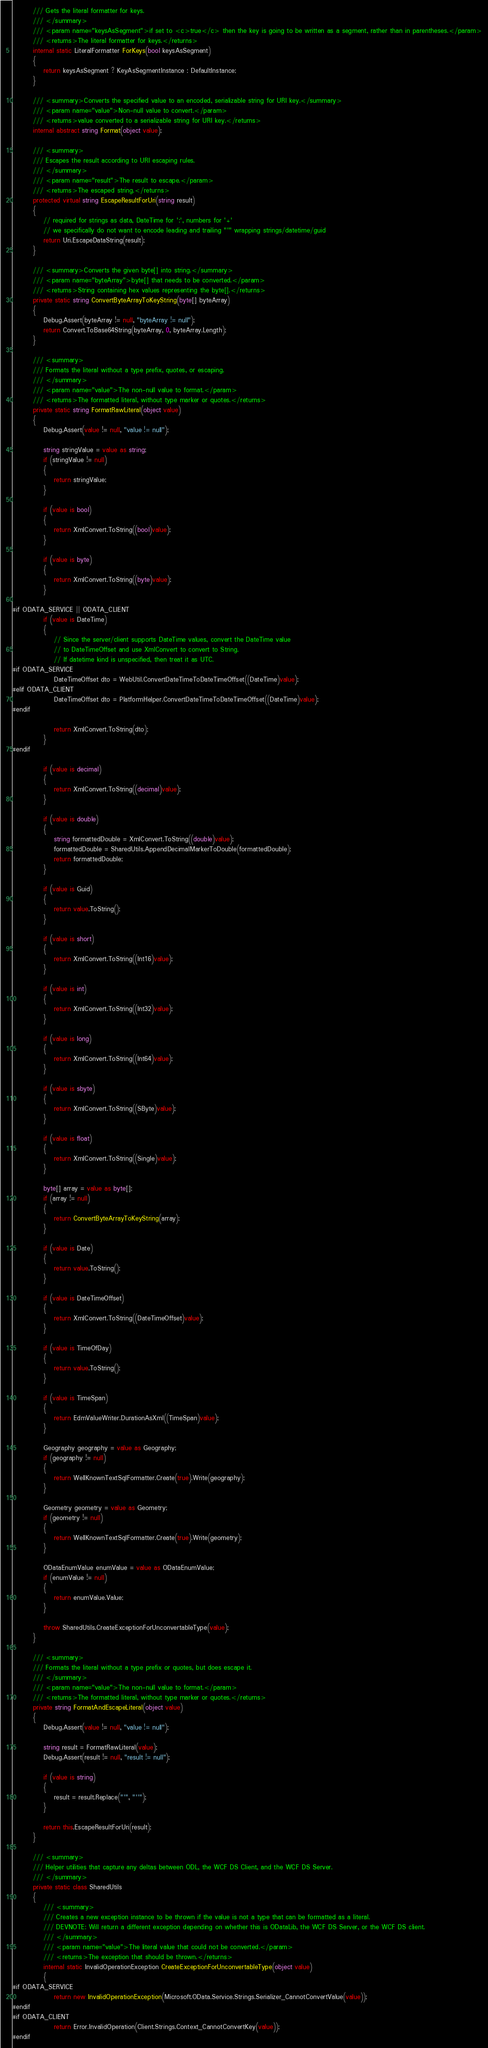Convert code to text. <code><loc_0><loc_0><loc_500><loc_500><_C#_>        /// Gets the literal formatter for keys.
        /// </summary>
        /// <param name="keysAsSegment">if set to <c>true</c> then the key is going to be written as a segment, rather than in parentheses.</param>
        /// <returns>The literal formatter for keys.</returns>
        internal static LiteralFormatter ForKeys(bool keysAsSegment)
        {
            return keysAsSegment ? KeyAsSegmentInstance : DefaultInstance;
        }

        /// <summary>Converts the specified value to an encoded, serializable string for URI key.</summary>
        /// <param name="value">Non-null value to convert.</param>
        /// <returns>value converted to a serializable string for URI key.</returns>
        internal abstract string Format(object value);

        /// <summary>
        /// Escapes the result according to URI escaping rules.
        /// </summary>
        /// <param name="result">The result to escape.</param>
        /// <returns>The escaped string.</returns>
        protected virtual string EscapeResultForUri(string result)
        {
            // required for strings as data, DateTime for ':', numbers for '+'
            // we specifically do not want to encode leading and trailing "'" wrapping strings/datetime/guid
            return Uri.EscapeDataString(result);
        }

        /// <summary>Converts the given byte[] into string.</summary>
        /// <param name="byteArray">byte[] that needs to be converted.</param>
        /// <returns>String containing hex values representing the byte[].</returns>
        private static string ConvertByteArrayToKeyString(byte[] byteArray)
        {
            Debug.Assert(byteArray != null, "byteArray != null");
            return Convert.ToBase64String(byteArray, 0, byteArray.Length);
        }

        /// <summary>
        /// Formats the literal without a type prefix, quotes, or escaping.
        /// </summary>
        /// <param name="value">The non-null value to format.</param>
        /// <returns>The formatted literal, without type marker or quotes.</returns>
        private static string FormatRawLiteral(object value)
        {
            Debug.Assert(value != null, "value != null");

            string stringValue = value as string;
            if (stringValue != null)
            {
                return stringValue;
            }

            if (value is bool)
            {
                return XmlConvert.ToString((bool)value);
            }

            if (value is byte)
            {
                return XmlConvert.ToString((byte)value);
            }

#if ODATA_SERVICE || ODATA_CLIENT
            if (value is DateTime)
            {
                // Since the server/client supports DateTime values, convert the DateTime value
                // to DateTimeOffset and use XmlConvert to convert to String.
                // If datetime kind is unspecified, then treat it as UTC.
#if ODATA_SERVICE
                DateTimeOffset dto = WebUtil.ConvertDateTimeToDateTimeOffset((DateTime)value);
#elif ODATA_CLIENT
                DateTimeOffset dto = PlatformHelper.ConvertDateTimeToDateTimeOffset((DateTime)value);
#endif

                return XmlConvert.ToString(dto);
            }
#endif

            if (value is decimal)
            {
                return XmlConvert.ToString((decimal)value);
            }

            if (value is double)
            {
                string formattedDouble = XmlConvert.ToString((double)value);
                formattedDouble = SharedUtils.AppendDecimalMarkerToDouble(formattedDouble);
                return formattedDouble;
            }

            if (value is Guid)
            {
                return value.ToString();
            }

            if (value is short)
            {
                return XmlConvert.ToString((Int16)value);
            }

            if (value is int)
            {
                return XmlConvert.ToString((Int32)value);
            }

            if (value is long)
            {
                return XmlConvert.ToString((Int64)value);
            }

            if (value is sbyte)
            {
                return XmlConvert.ToString((SByte)value);
            }

            if (value is float)
            {
                return XmlConvert.ToString((Single)value);
            }

            byte[] array = value as byte[];
            if (array != null)
            {
                return ConvertByteArrayToKeyString(array);
            }

            if (value is Date)
            {
                return value.ToString();
            }

            if (value is DateTimeOffset)
            {
                return XmlConvert.ToString((DateTimeOffset)value);
            }

            if (value is TimeOfDay)
            {
                return value.ToString();
            }

            if (value is TimeSpan)
            {
                return EdmValueWriter.DurationAsXml((TimeSpan)value);
            }

            Geography geography = value as Geography;
            if (geography != null)
            {
                return WellKnownTextSqlFormatter.Create(true).Write(geography);
            }

            Geometry geometry = value as Geometry;
            if (geometry != null)
            {
                return WellKnownTextSqlFormatter.Create(true).Write(geometry);
            }

            ODataEnumValue enumValue = value as ODataEnumValue;
            if (enumValue != null)
            {
                return enumValue.Value;
            }

            throw SharedUtils.CreateExceptionForUnconvertableType(value);
        }

        /// <summary>
        /// Formats the literal without a type prefix or quotes, but does escape it.
        /// </summary>
        /// <param name="value">The non-null value to format.</param>
        /// <returns>The formatted literal, without type marker or quotes.</returns>
        private string FormatAndEscapeLiteral(object value)
        {
            Debug.Assert(value != null, "value != null");

            string result = FormatRawLiteral(value);
            Debug.Assert(result != null, "result != null");

            if (value is string)
            {
                result = result.Replace("'", "''");
            }

            return this.EscapeResultForUri(result);
        }

        /// <summary>
        /// Helper utilities that capture any deltas between ODL, the WCF DS Client, and the WCF DS Server.
        /// </summary>
        private static class SharedUtils
        {
            /// <summary>
            /// Creates a new exception instance to be thrown if the value is not a type that can be formatted as a literal.
            /// DEVNOTE: Will return a different exception depending on whether this is ODataLib, the WCF DS Server, or the WCF DS client.
            /// </summary>
            /// <param name="value">The literal value that could not be converted.</param>
            /// <returns>The exception that should be thrown.</returns>
            internal static InvalidOperationException CreateExceptionForUnconvertableType(object value)
            {
#if ODATA_SERVICE
                return new InvalidOperationException(Microsoft.OData.Service.Strings.Serializer_CannotConvertValue(value));
#endif
#if ODATA_CLIENT
                return Error.InvalidOperation(Client.Strings.Context_CannotConvertKey(value));
#endif</code> 